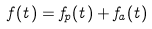<formula> <loc_0><loc_0><loc_500><loc_500>f ( t ) = f _ { p } ( t ) + f _ { a } ( t )</formula> 